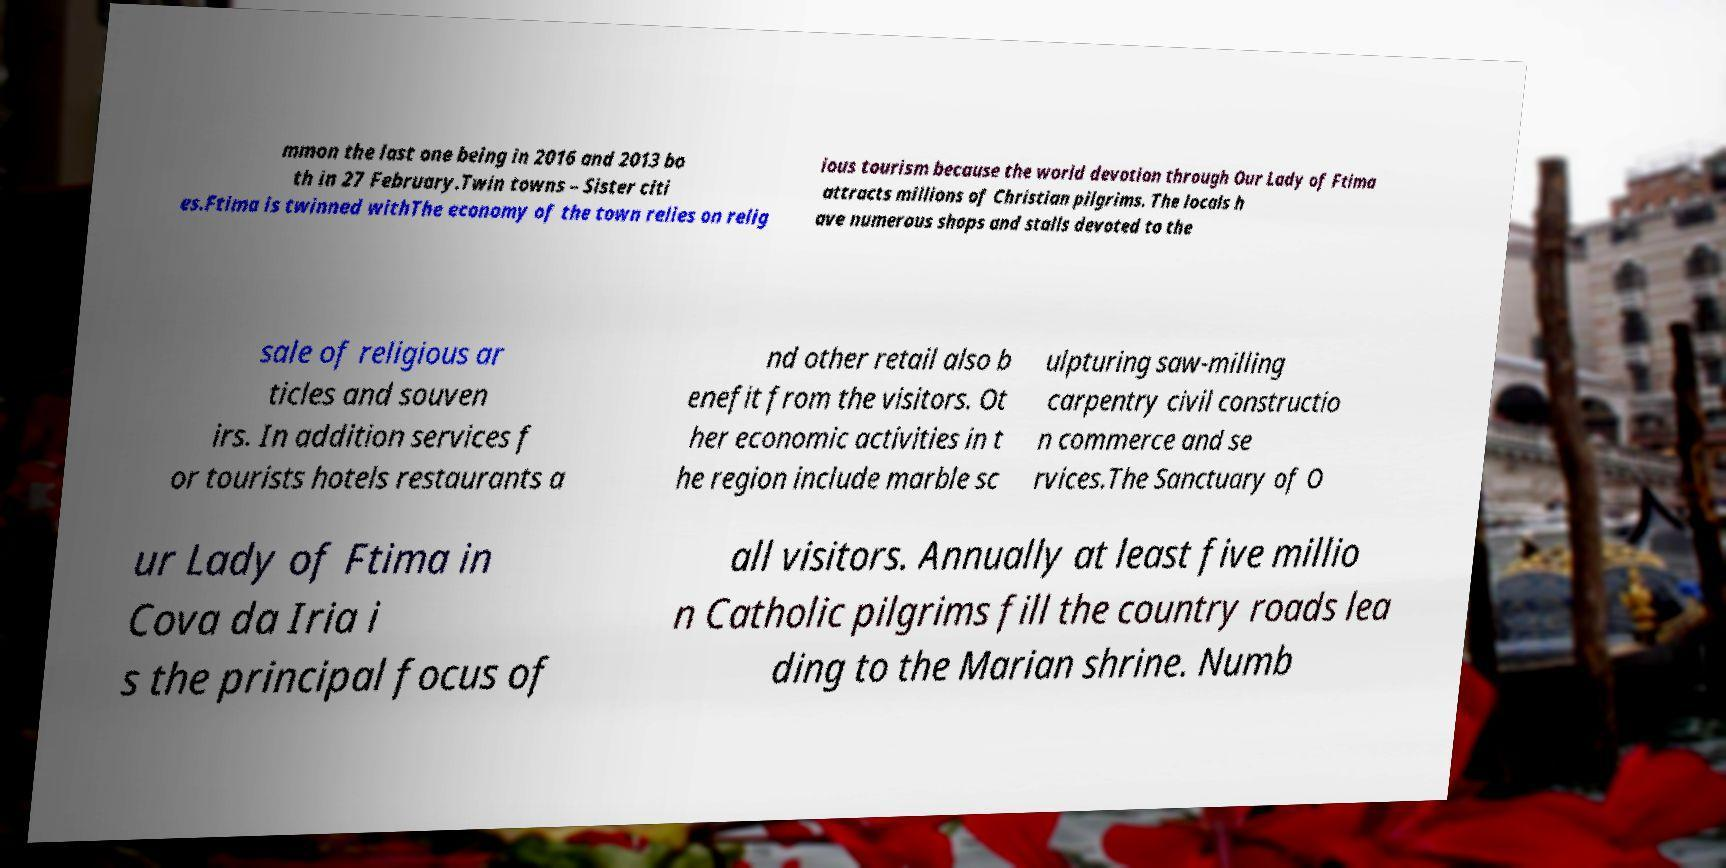What messages or text are displayed in this image? I need them in a readable, typed format. mmon the last one being in 2016 and 2013 bo th in 27 February.Twin towns – Sister citi es.Ftima is twinned withThe economy of the town relies on relig ious tourism because the world devotion through Our Lady of Ftima attracts millions of Christian pilgrims. The locals h ave numerous shops and stalls devoted to the sale of religious ar ticles and souven irs. In addition services f or tourists hotels restaurants a nd other retail also b enefit from the visitors. Ot her economic activities in t he region include marble sc ulpturing saw-milling carpentry civil constructio n commerce and se rvices.The Sanctuary of O ur Lady of Ftima in Cova da Iria i s the principal focus of all visitors. Annually at least five millio n Catholic pilgrims fill the country roads lea ding to the Marian shrine. Numb 